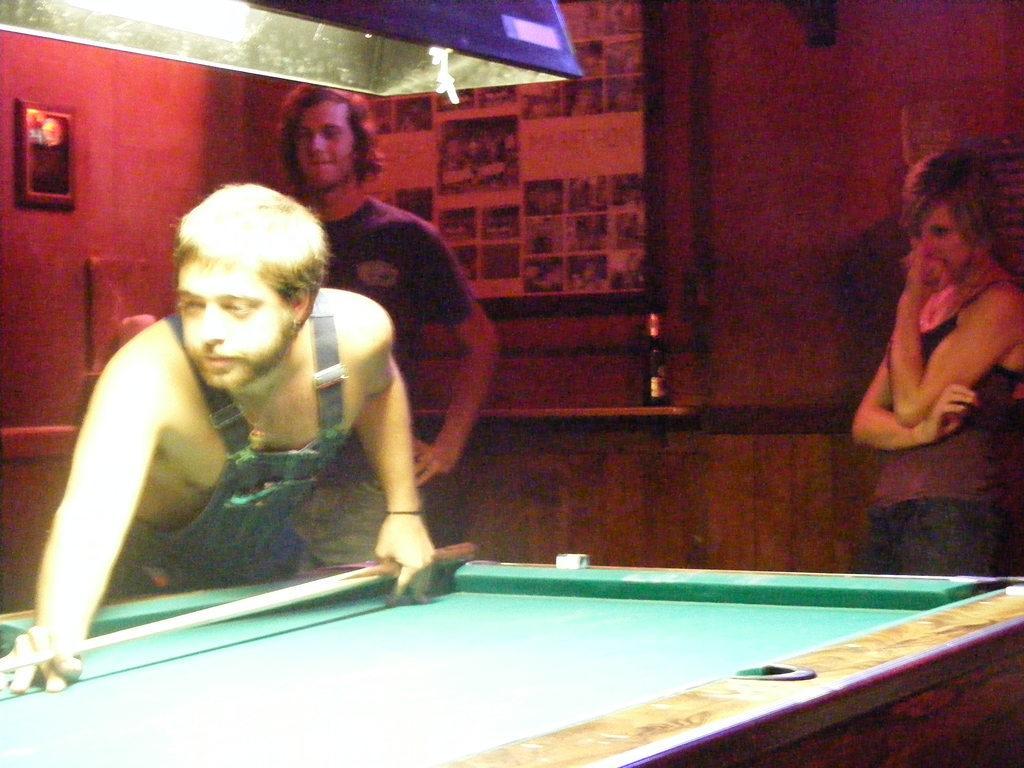Describe this image in one or two sentences. Here we can see a man holding a snooker stick probably playing Snooker on snooker board and behind him we can see a man and a woman standing and there is a bottle of beer kept on the plank present here 